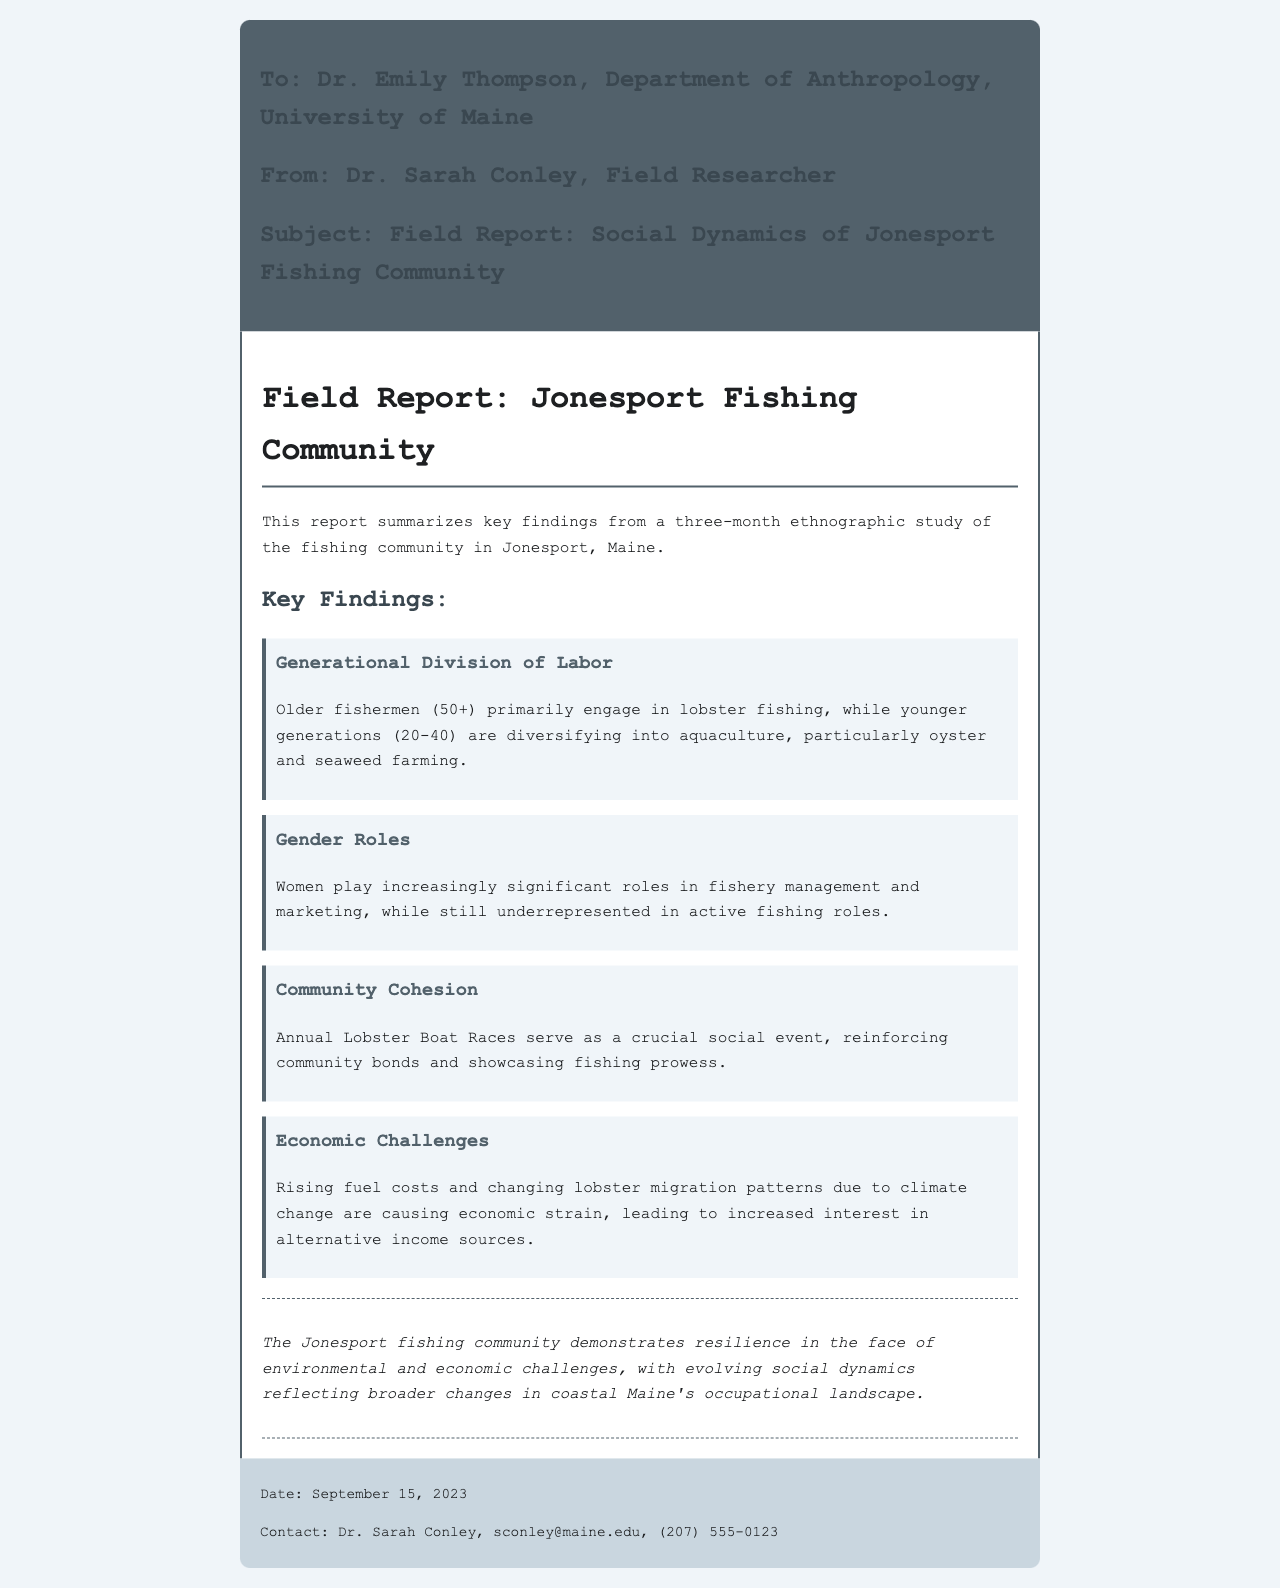what is the name of the community studied? The report focuses on the fishing community located in Jonesport, Maine.
Answer: Jonesport who authored the report? The report was authored by Dr. Sarah Conley, as indicated in the header.
Answer: Dr. Sarah Conley what key economic challenge is mentioned? The report highlights rising fuel costs as a significant economic challenge faced by the community.
Answer: Rising fuel costs which demographic primarily engages in lobster fishing? The report states that older fishermen, specifically those aged 50 and above, mainly participate in lobster fishing.
Answer: Older fishermen (50+) what event reinforces community bonds? The annual Lobster Boat Races are identified as a crucial social event that strengthens community connections.
Answer: Annual Lobster Boat Races how long did the ethnographic study last? The duration of the study is specified as three months in the introduction of the report.
Answer: Three months what type of farming are younger generations diversifying into? The younger generations are diversifying into aquaculture, particularly focusing on oyster and seaweed farming.
Answer: Aquaculture what is the date of the report? The report includes a specific date in the footer, indicating when it was sent.
Answer: September 15, 2023 